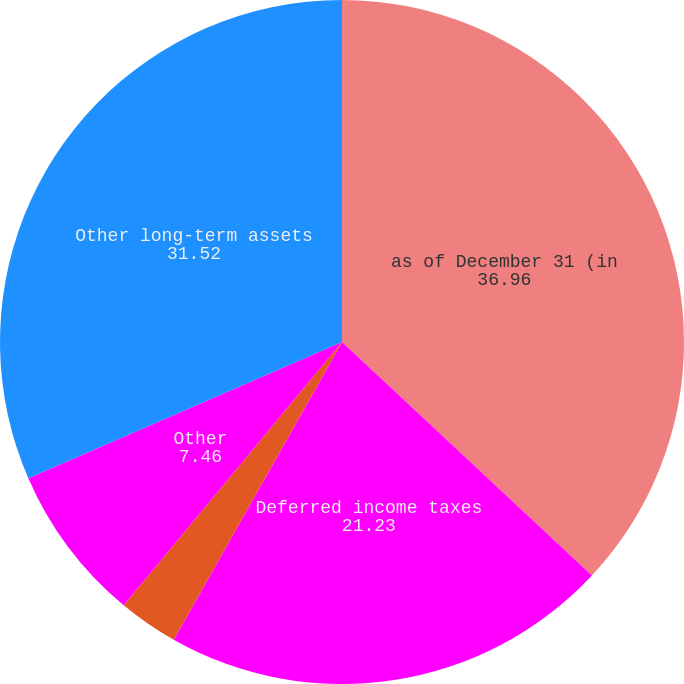Convert chart to OTSL. <chart><loc_0><loc_0><loc_500><loc_500><pie_chart><fcel>as of December 31 (in<fcel>Deferred income taxes<fcel>Other long-term receivables<fcel>Other<fcel>Other long-term assets<nl><fcel>36.96%<fcel>21.23%<fcel>2.83%<fcel>7.46%<fcel>31.52%<nl></chart> 